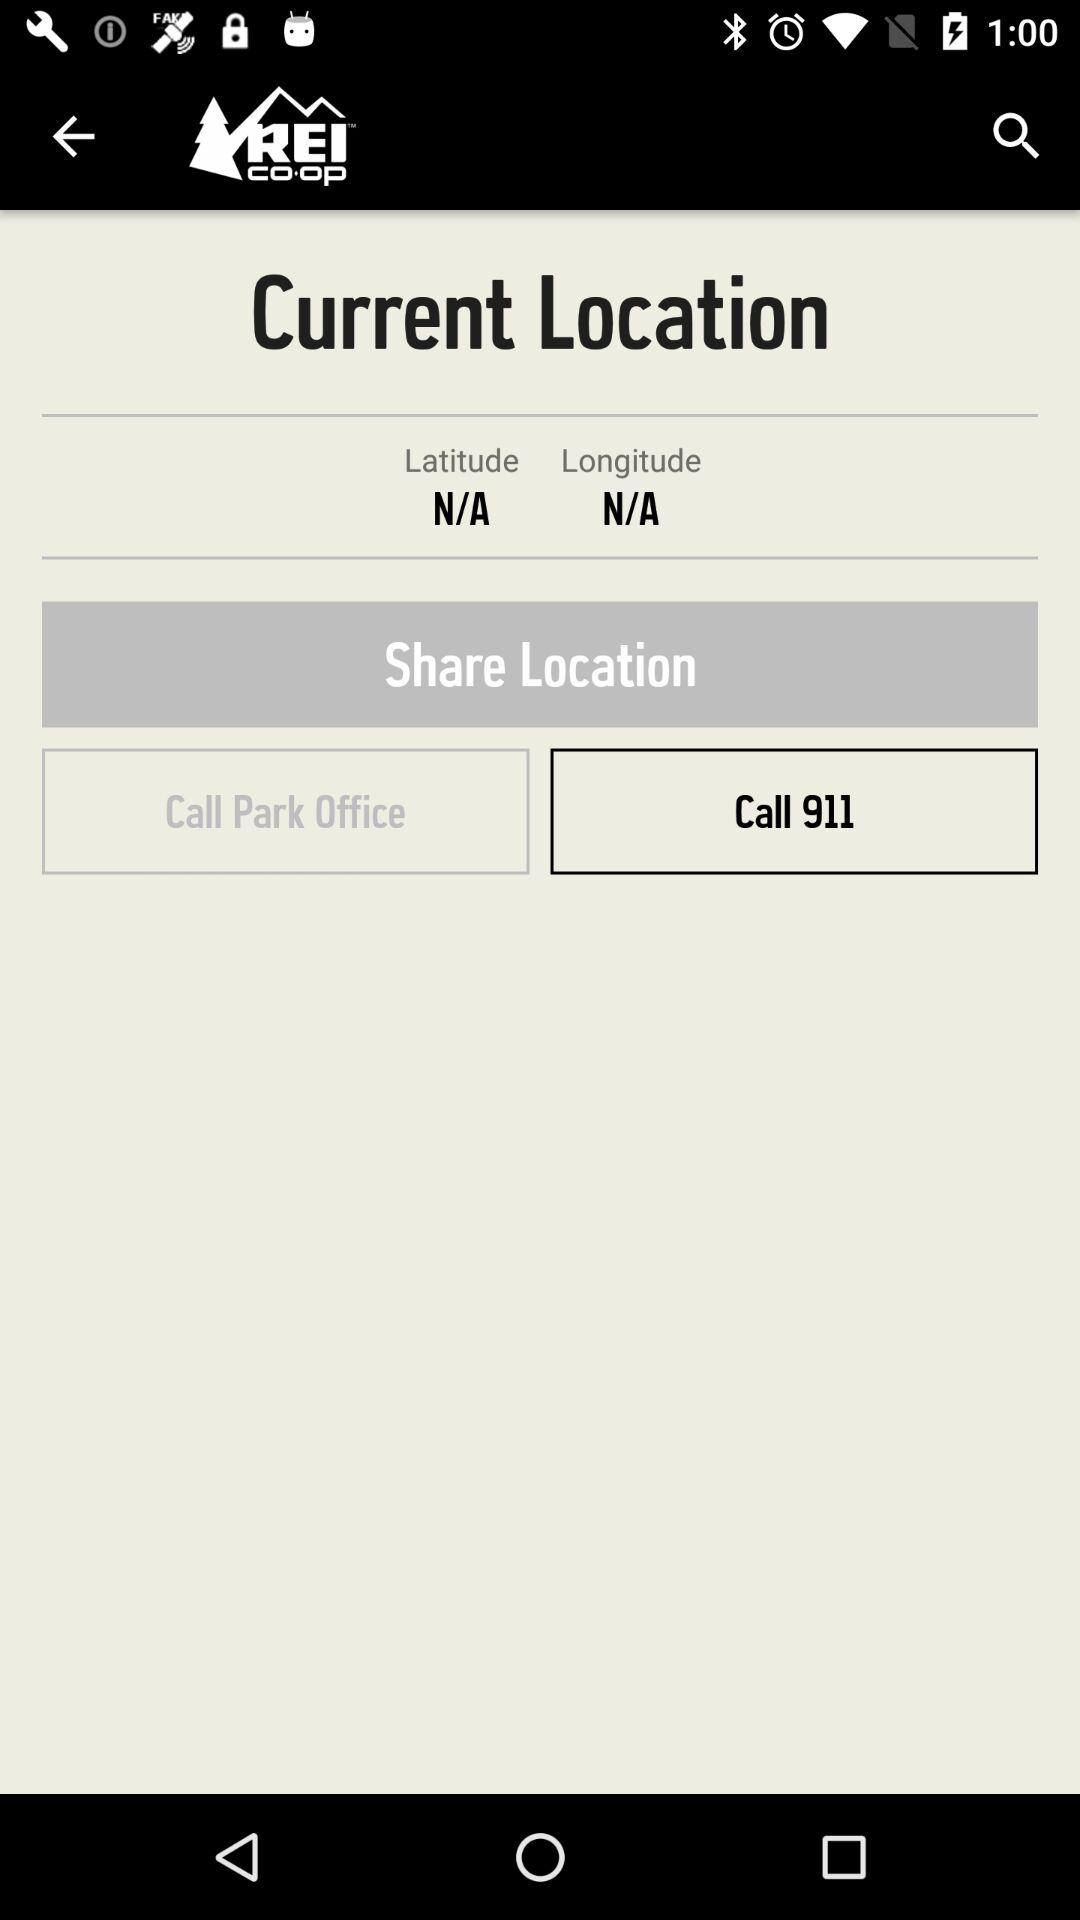What is the application name? The application name is "REI co-op". 